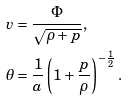Convert formula to latex. <formula><loc_0><loc_0><loc_500><loc_500>v & = \frac { \Phi } { \sqrt { \rho + p } } , \\ \theta & = \frac { 1 } { a } \left ( 1 + \frac { p } { \rho } \right ) ^ { - \frac { 1 } { 2 } } .</formula> 